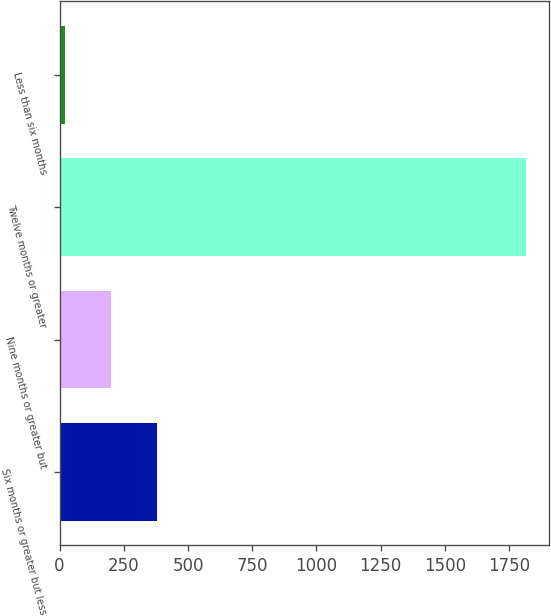<chart> <loc_0><loc_0><loc_500><loc_500><bar_chart><fcel>Six months or greater but less<fcel>Nine months or greater but<fcel>Twelve months or greater<fcel>Less than six months<nl><fcel>380.6<fcel>201.3<fcel>1815<fcel>22<nl></chart> 